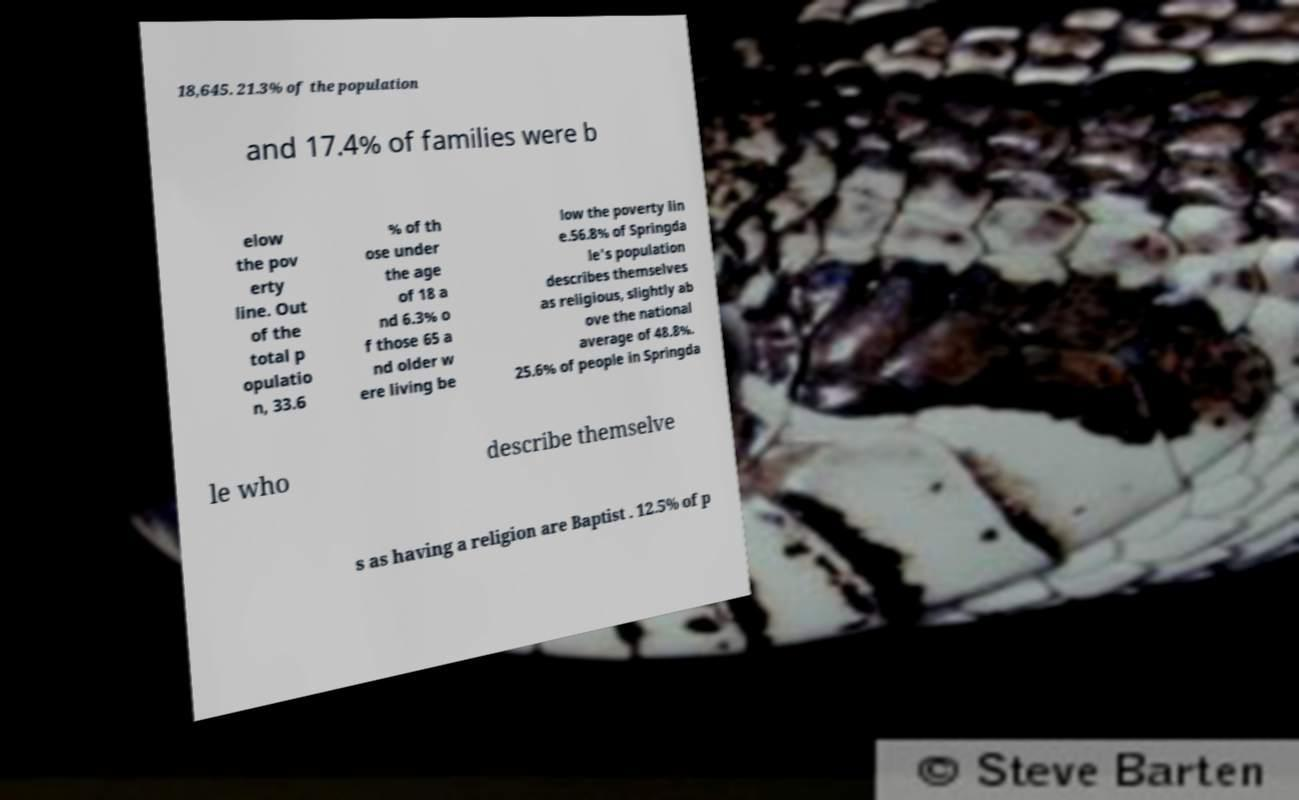Please identify and transcribe the text found in this image. 18,645. 21.3% of the population and 17.4% of families were b elow the pov erty line. Out of the total p opulatio n, 33.6 % of th ose under the age of 18 a nd 6.3% o f those 65 a nd older w ere living be low the poverty lin e.56.8% of Springda le's population describes themselves as religious, slightly ab ove the national average of 48.8%. 25.6% of people in Springda le who describe themselve s as having a religion are Baptist . 12.5% of p 